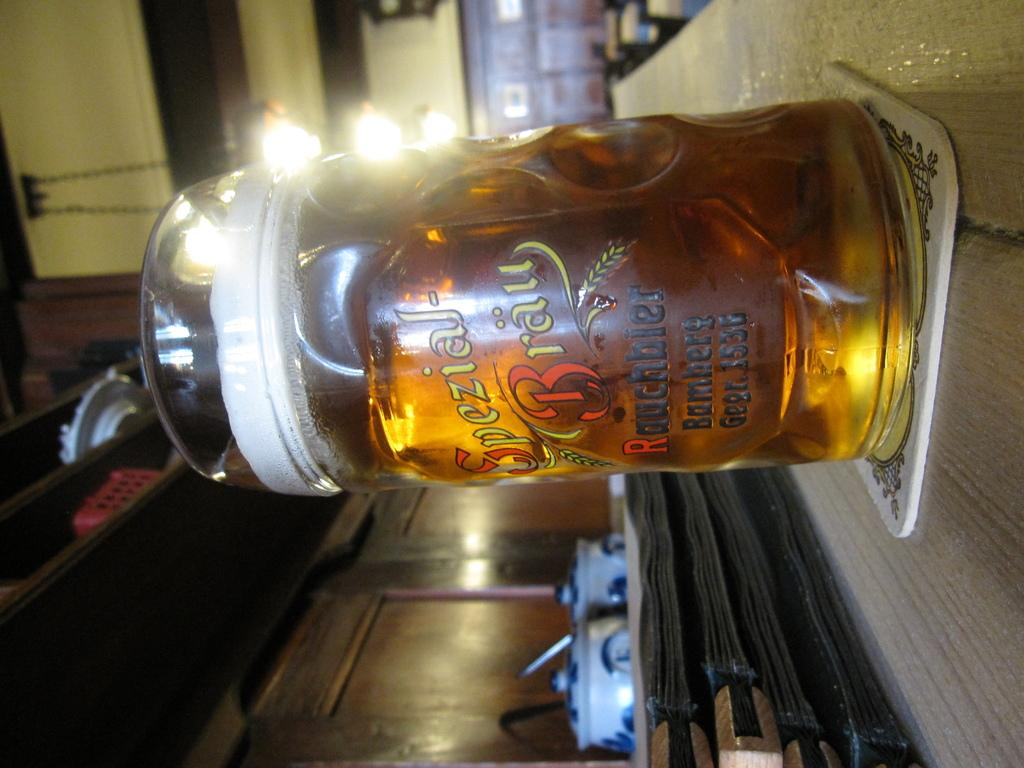<image>
Relay a brief, clear account of the picture shown. A glass of beer at a pub that was opened in 1536. 